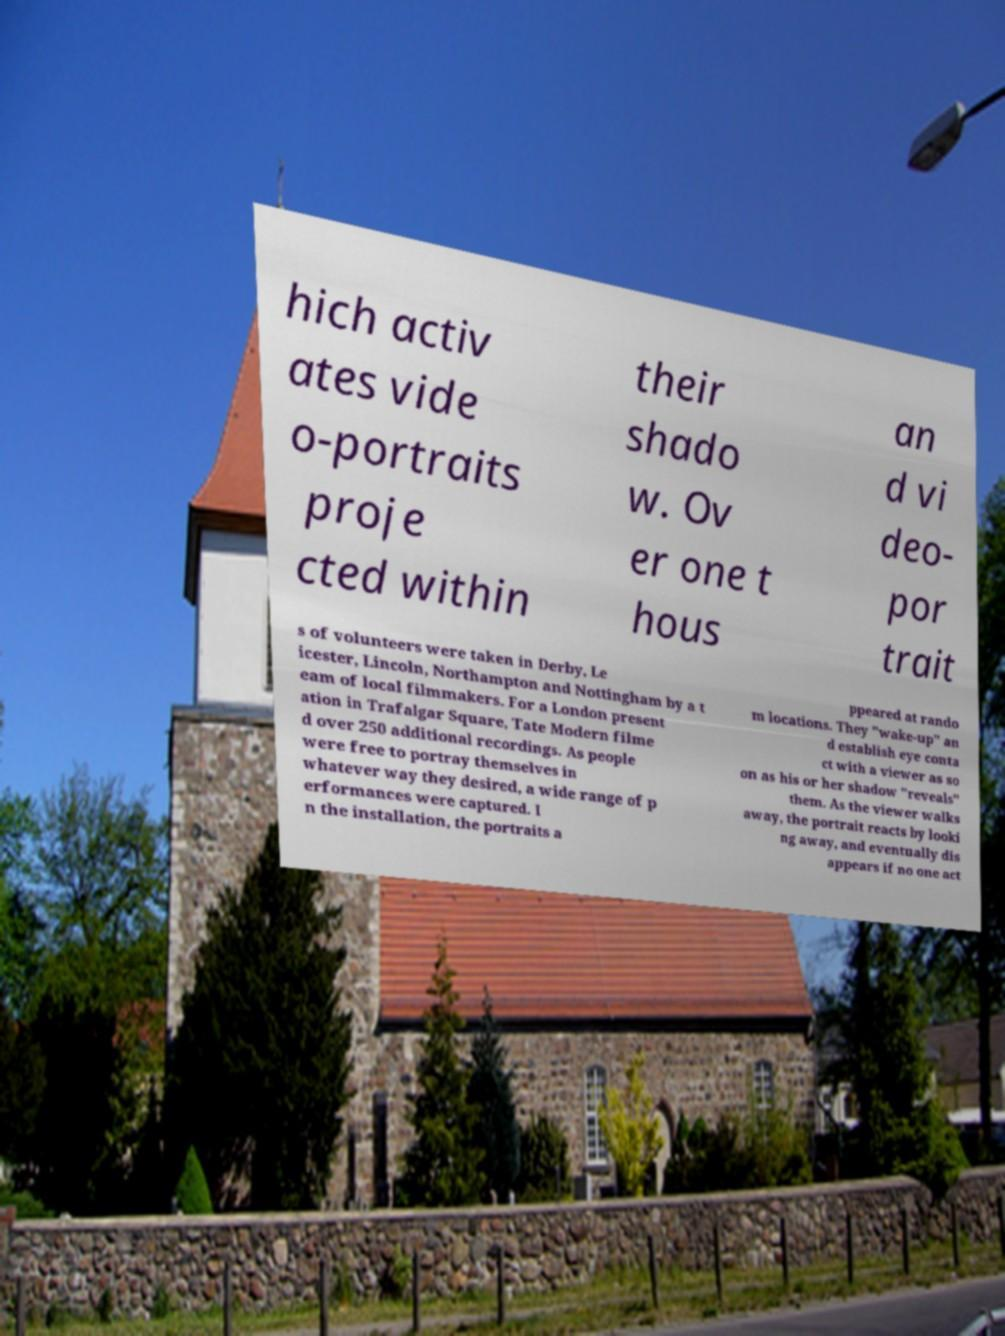Could you extract and type out the text from this image? hich activ ates vide o-portraits proje cted within their shado w. Ov er one t hous an d vi deo- por trait s of volunteers were taken in Derby, Le icester, Lincoln, Northampton and Nottingham by a t eam of local filmmakers. For a London present ation in Trafalgar Square, Tate Modern filme d over 250 additional recordings. As people were free to portray themselves in whatever way they desired, a wide range of p erformances were captured. I n the installation, the portraits a ppeared at rando m locations. They "wake-up" an d establish eye conta ct with a viewer as so on as his or her shadow "reveals" them. As the viewer walks away, the portrait reacts by looki ng away, and eventually dis appears if no one act 